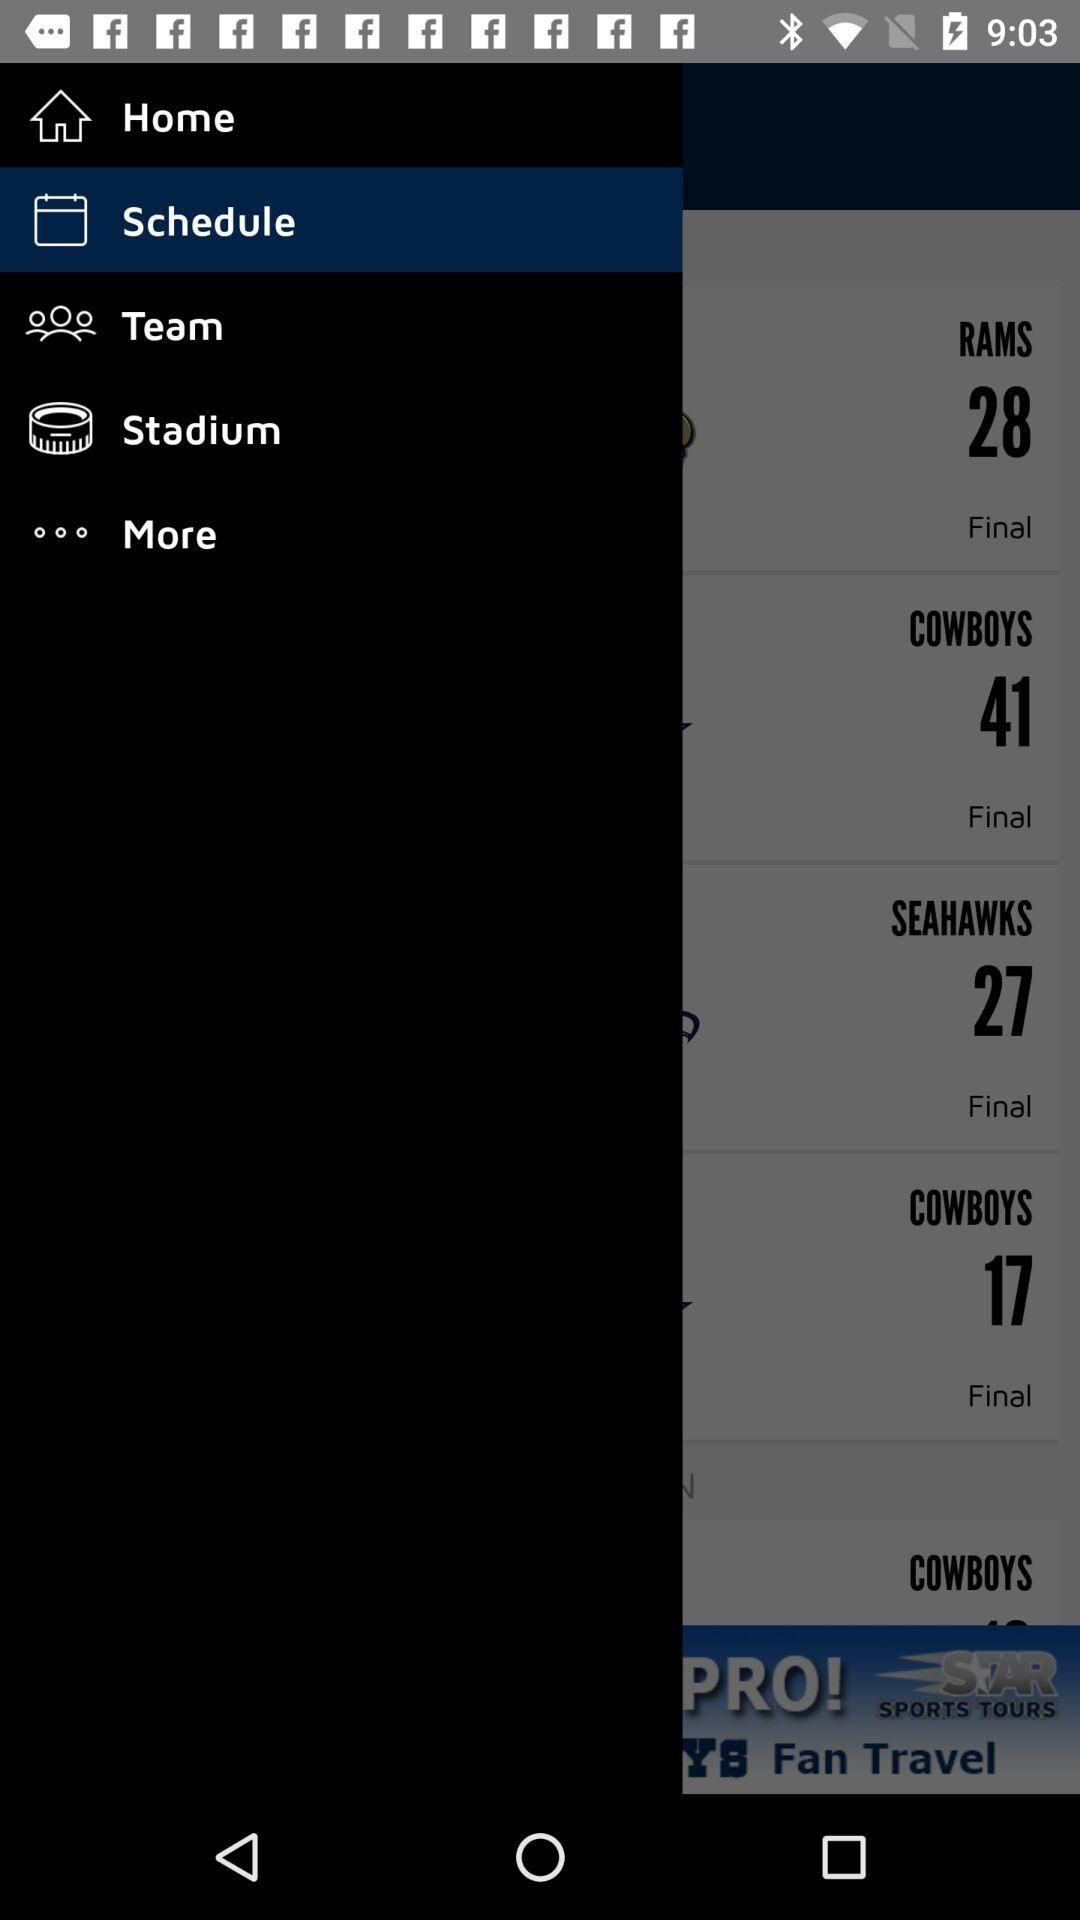How many more points did the Cowboys score than the Seahawks?
Answer the question using a single word or phrase. 14 